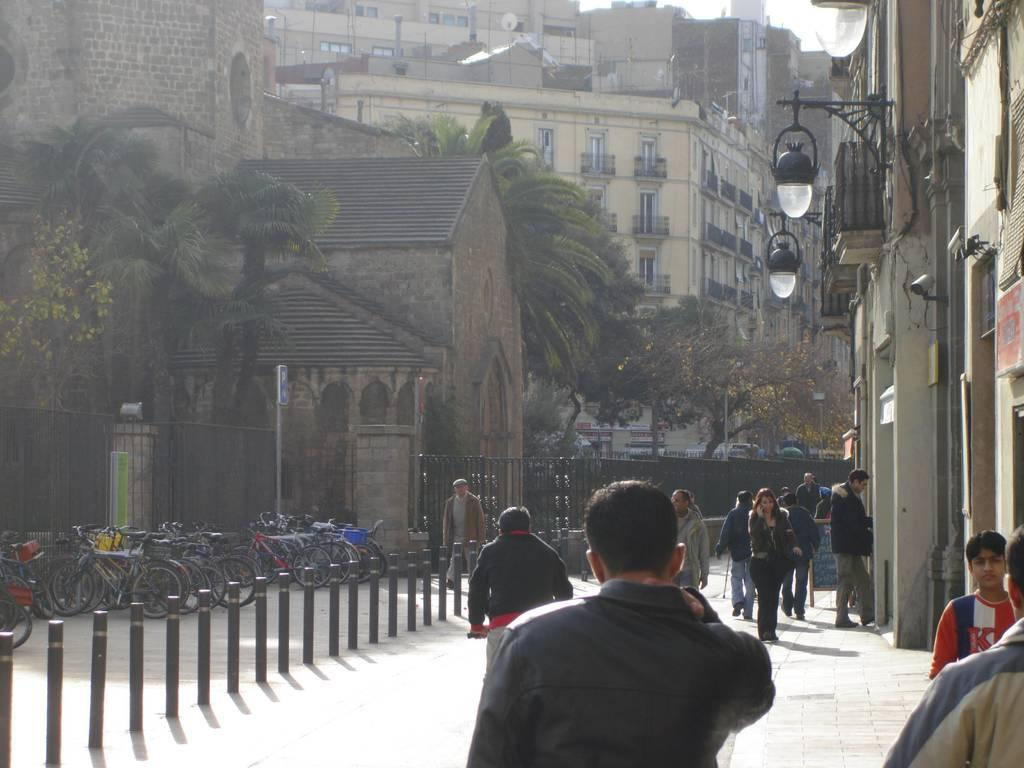What are the people in the image doing? The people in the image are walking on the road. What mode of transportation is not in use in the image? Bicycles are parked in the image, so they are not being used. What type of barrier is present in the image? There is a fence in the image. What can be seen illuminating the scene in the image? Lights are visible in the image. What type of structures are present in the image? Houses are present in the image. What type of natural elements are present in the image? Trees are present in the image. What type of vegetable is being sold at the club in the image? There is no club or vegetable present in the image. How much money is being exchanged between the people in the image? There is no indication of any money exchange in the image. 